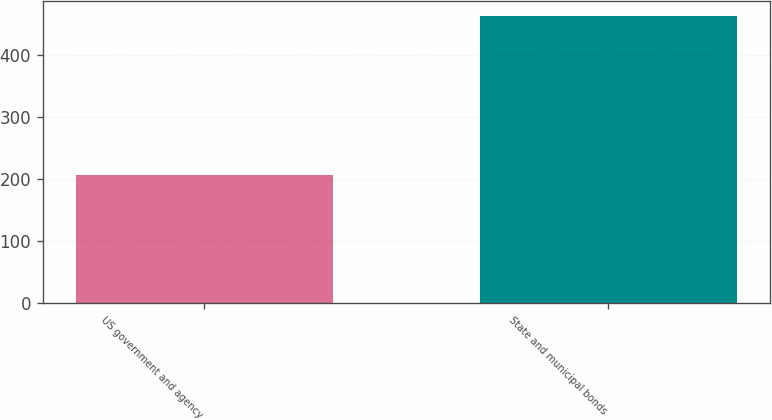Convert chart to OTSL. <chart><loc_0><loc_0><loc_500><loc_500><bar_chart><fcel>US government and agency<fcel>State and municipal bonds<nl><fcel>207<fcel>464<nl></chart> 